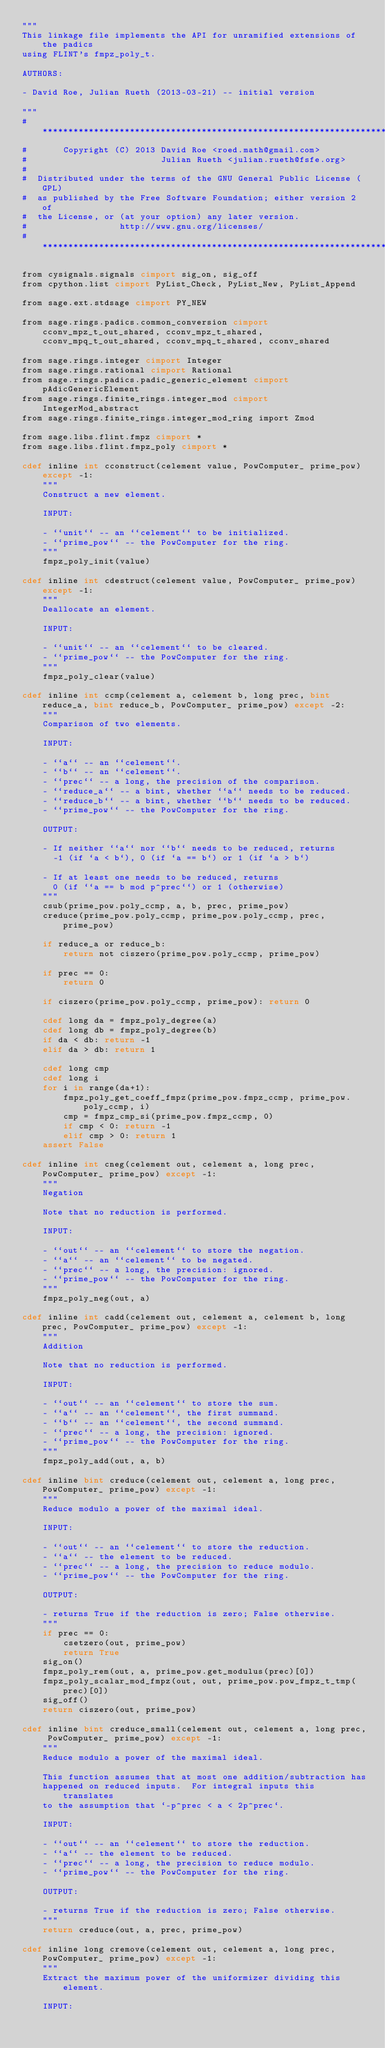<code> <loc_0><loc_0><loc_500><loc_500><_Cython_>"""
This linkage file implements the API for unramified extensions of the padics
using FLINT's fmpz_poly_t.

AUTHORS:

- David Roe, Julian Rueth (2013-03-21) -- initial version

"""
#*****************************************************************************
#       Copyright (C) 2013 David Roe <roed.math@gmail.com>
#                          Julian Rueth <julian.rueth@fsfe.org>
#
#  Distributed under the terms of the GNU General Public License (GPL)
#  as published by the Free Software Foundation; either version 2 of
#  the License, or (at your option) any later version.
#                  http://www.gnu.org/licenses/
#*****************************************************************************

from cysignals.signals cimport sig_on, sig_off
from cpython.list cimport PyList_Check, PyList_New, PyList_Append

from sage.ext.stdsage cimport PY_NEW

from sage.rings.padics.common_conversion cimport cconv_mpz_t_out_shared, cconv_mpz_t_shared, cconv_mpq_t_out_shared, cconv_mpq_t_shared, cconv_shared

from sage.rings.integer cimport Integer
from sage.rings.rational cimport Rational
from sage.rings.padics.padic_generic_element cimport pAdicGenericElement
from sage.rings.finite_rings.integer_mod cimport IntegerMod_abstract
from sage.rings.finite_rings.integer_mod_ring import Zmod

from sage.libs.flint.fmpz cimport *
from sage.libs.flint.fmpz_poly cimport *

cdef inline int cconstruct(celement value, PowComputer_ prime_pow) except -1:
    """
    Construct a new element.

    INPUT:

    - ``unit`` -- an ``celement`` to be initialized.
    - ``prime_pow`` -- the PowComputer for the ring.
    """
    fmpz_poly_init(value)

cdef inline int cdestruct(celement value, PowComputer_ prime_pow) except -1:
    """
    Deallocate an element.

    INPUT:

    - ``unit`` -- an ``celement`` to be cleared.
    - ``prime_pow`` -- the PowComputer for the ring.
    """
    fmpz_poly_clear(value)

cdef inline int ccmp(celement a, celement b, long prec, bint reduce_a, bint reduce_b, PowComputer_ prime_pow) except -2:
    """
    Comparison of two elements.

    INPUT:

    - ``a`` -- an ``celement``.
    - ``b`` -- an ``celement``.
    - ``prec`` -- a long, the precision of the comparison.
    - ``reduce_a`` -- a bint, whether ``a`` needs to be reduced.
    - ``reduce_b`` -- a bint, whether ``b`` needs to be reduced.
    - ``prime_pow`` -- the PowComputer for the ring.

    OUTPUT:

    - If neither ``a`` nor ``b`` needs to be reduced, returns
      -1 (if `a < b`), 0 (if `a == b`) or 1 (if `a > b`)

    - If at least one needs to be reduced, returns
      0 (if ``a == b mod p^prec``) or 1 (otherwise)
    """
    csub(prime_pow.poly_ccmp, a, b, prec, prime_pow)
    creduce(prime_pow.poly_ccmp, prime_pow.poly_ccmp, prec, prime_pow)

    if reduce_a or reduce_b:
        return not ciszero(prime_pow.poly_ccmp, prime_pow)

    if prec == 0:
        return 0

    if ciszero(prime_pow.poly_ccmp, prime_pow): return 0

    cdef long da = fmpz_poly_degree(a)
    cdef long db = fmpz_poly_degree(b)
    if da < db: return -1
    elif da > db: return 1

    cdef long cmp
    cdef long i
    for i in range(da+1):
        fmpz_poly_get_coeff_fmpz(prime_pow.fmpz_ccmp, prime_pow.poly_ccmp, i)
        cmp = fmpz_cmp_si(prime_pow.fmpz_ccmp, 0)
        if cmp < 0: return -1
        elif cmp > 0: return 1
    assert False

cdef inline int cneg(celement out, celement a, long prec, PowComputer_ prime_pow) except -1:
    """
    Negation

    Note that no reduction is performed.

    INPUT:

    - ``out`` -- an ``celement`` to store the negation.
    - ``a`` -- an ``celement`` to be negated.
    - ``prec`` -- a long, the precision: ignored.
    - ``prime_pow`` -- the PowComputer for the ring.
    """
    fmpz_poly_neg(out, a)

cdef inline int cadd(celement out, celement a, celement b, long prec, PowComputer_ prime_pow) except -1:
    """
    Addition

    Note that no reduction is performed.

    INPUT:

    - ``out`` -- an ``celement`` to store the sum.
    - ``a`` -- an ``celement``, the first summand.
    - ``b`` -- an ``celement``, the second summand.
    - ``prec`` -- a long, the precision: ignored.
    - ``prime_pow`` -- the PowComputer for the ring.
    """
    fmpz_poly_add(out, a, b)

cdef inline bint creduce(celement out, celement a, long prec, PowComputer_ prime_pow) except -1:
    """
    Reduce modulo a power of the maximal ideal.

    INPUT:

    - ``out`` -- an ``celement`` to store the reduction.
    - ``a`` -- the element to be reduced.
    - ``prec`` -- a long, the precision to reduce modulo.
    - ``prime_pow`` -- the PowComputer for the ring.

    OUTPUT:

    - returns True if the reduction is zero; False otherwise.
    """
    if prec == 0:
        csetzero(out, prime_pow)
        return True
    sig_on()
    fmpz_poly_rem(out, a, prime_pow.get_modulus(prec)[0])
    fmpz_poly_scalar_mod_fmpz(out, out, prime_pow.pow_fmpz_t_tmp(prec)[0])
    sig_off()
    return ciszero(out, prime_pow)

cdef inline bint creduce_small(celement out, celement a, long prec, PowComputer_ prime_pow) except -1:
    """
    Reduce modulo a power of the maximal ideal.

    This function assumes that at most one addition/subtraction has
    happened on reduced inputs.  For integral inputs this translates
    to the assumption that `-p^prec < a < 2p^prec`.

    INPUT:

    - ``out`` -- an ``celement`` to store the reduction.
    - ``a`` -- the element to be reduced.
    - ``prec`` -- a long, the precision to reduce modulo.
    - ``prime_pow`` -- the PowComputer for the ring.

    OUTPUT:

    - returns True if the reduction is zero; False otherwise.
    """
    return creduce(out, a, prec, prime_pow)

cdef inline long cremove(celement out, celement a, long prec, PowComputer_ prime_pow) except -1:
    """
    Extract the maximum power of the uniformizer dividing this element.

    INPUT:
</code> 